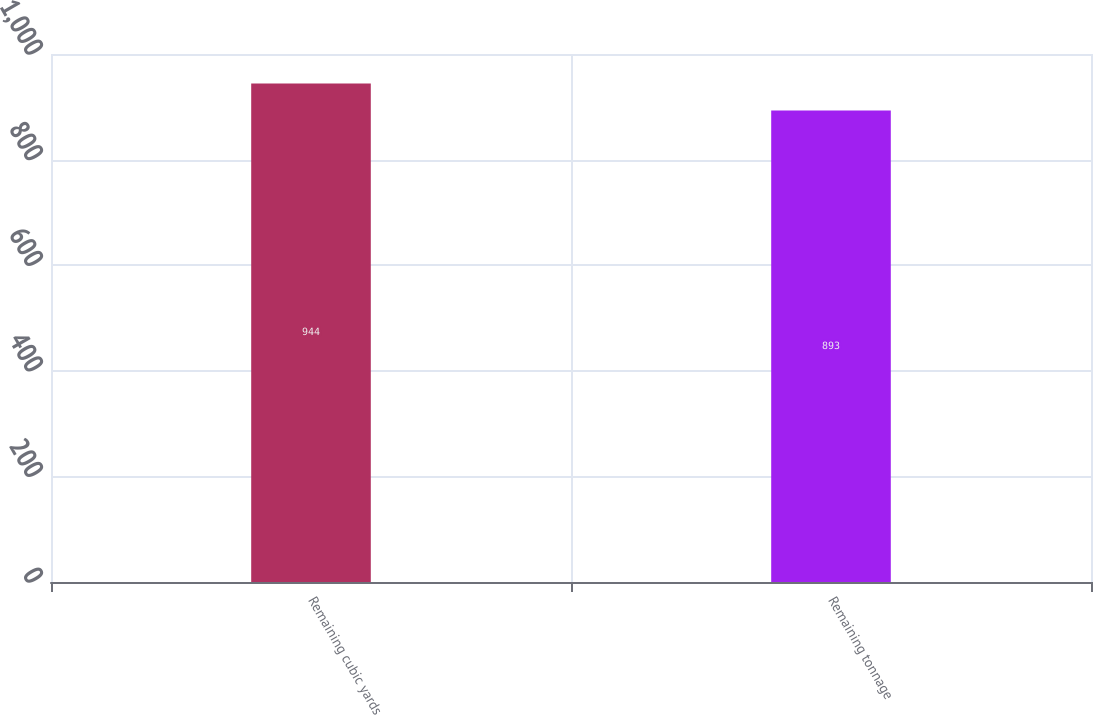<chart> <loc_0><loc_0><loc_500><loc_500><bar_chart><fcel>Remaining cubic yards<fcel>Remaining tonnage<nl><fcel>944<fcel>893<nl></chart> 